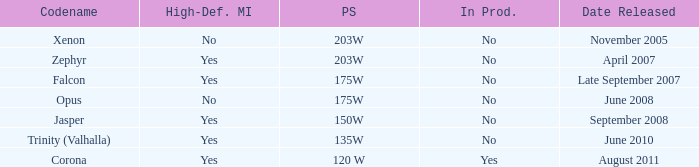Is Jasper being producted? No. 